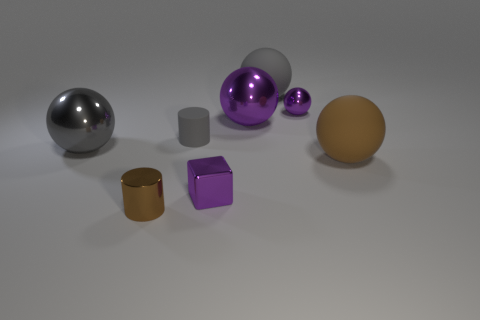Are the big gray object that is left of the rubber cylinder and the big purple ball made of the same material?
Keep it short and to the point. Yes. Do the tiny gray object and the brown metallic object have the same shape?
Offer a terse response. Yes. How many big spheres are in front of the gray sphere to the left of the purple cube?
Give a very brief answer. 1. There is another small thing that is the same shape as the brown shiny object; what is its material?
Your answer should be compact. Rubber. Do the large object that is in front of the large gray metallic ball and the metallic cylinder have the same color?
Ensure brevity in your answer.  Yes. Is the tiny purple ball made of the same material as the tiny cylinder that is behind the metallic cylinder?
Give a very brief answer. No. What shape is the big metallic thing that is on the right side of the brown cylinder?
Ensure brevity in your answer.  Sphere. How many other objects are the same material as the brown cylinder?
Your response must be concise. 4. How big is the metallic block?
Your answer should be compact. Small. What number of other things are the same color as the small sphere?
Provide a succinct answer. 2. 